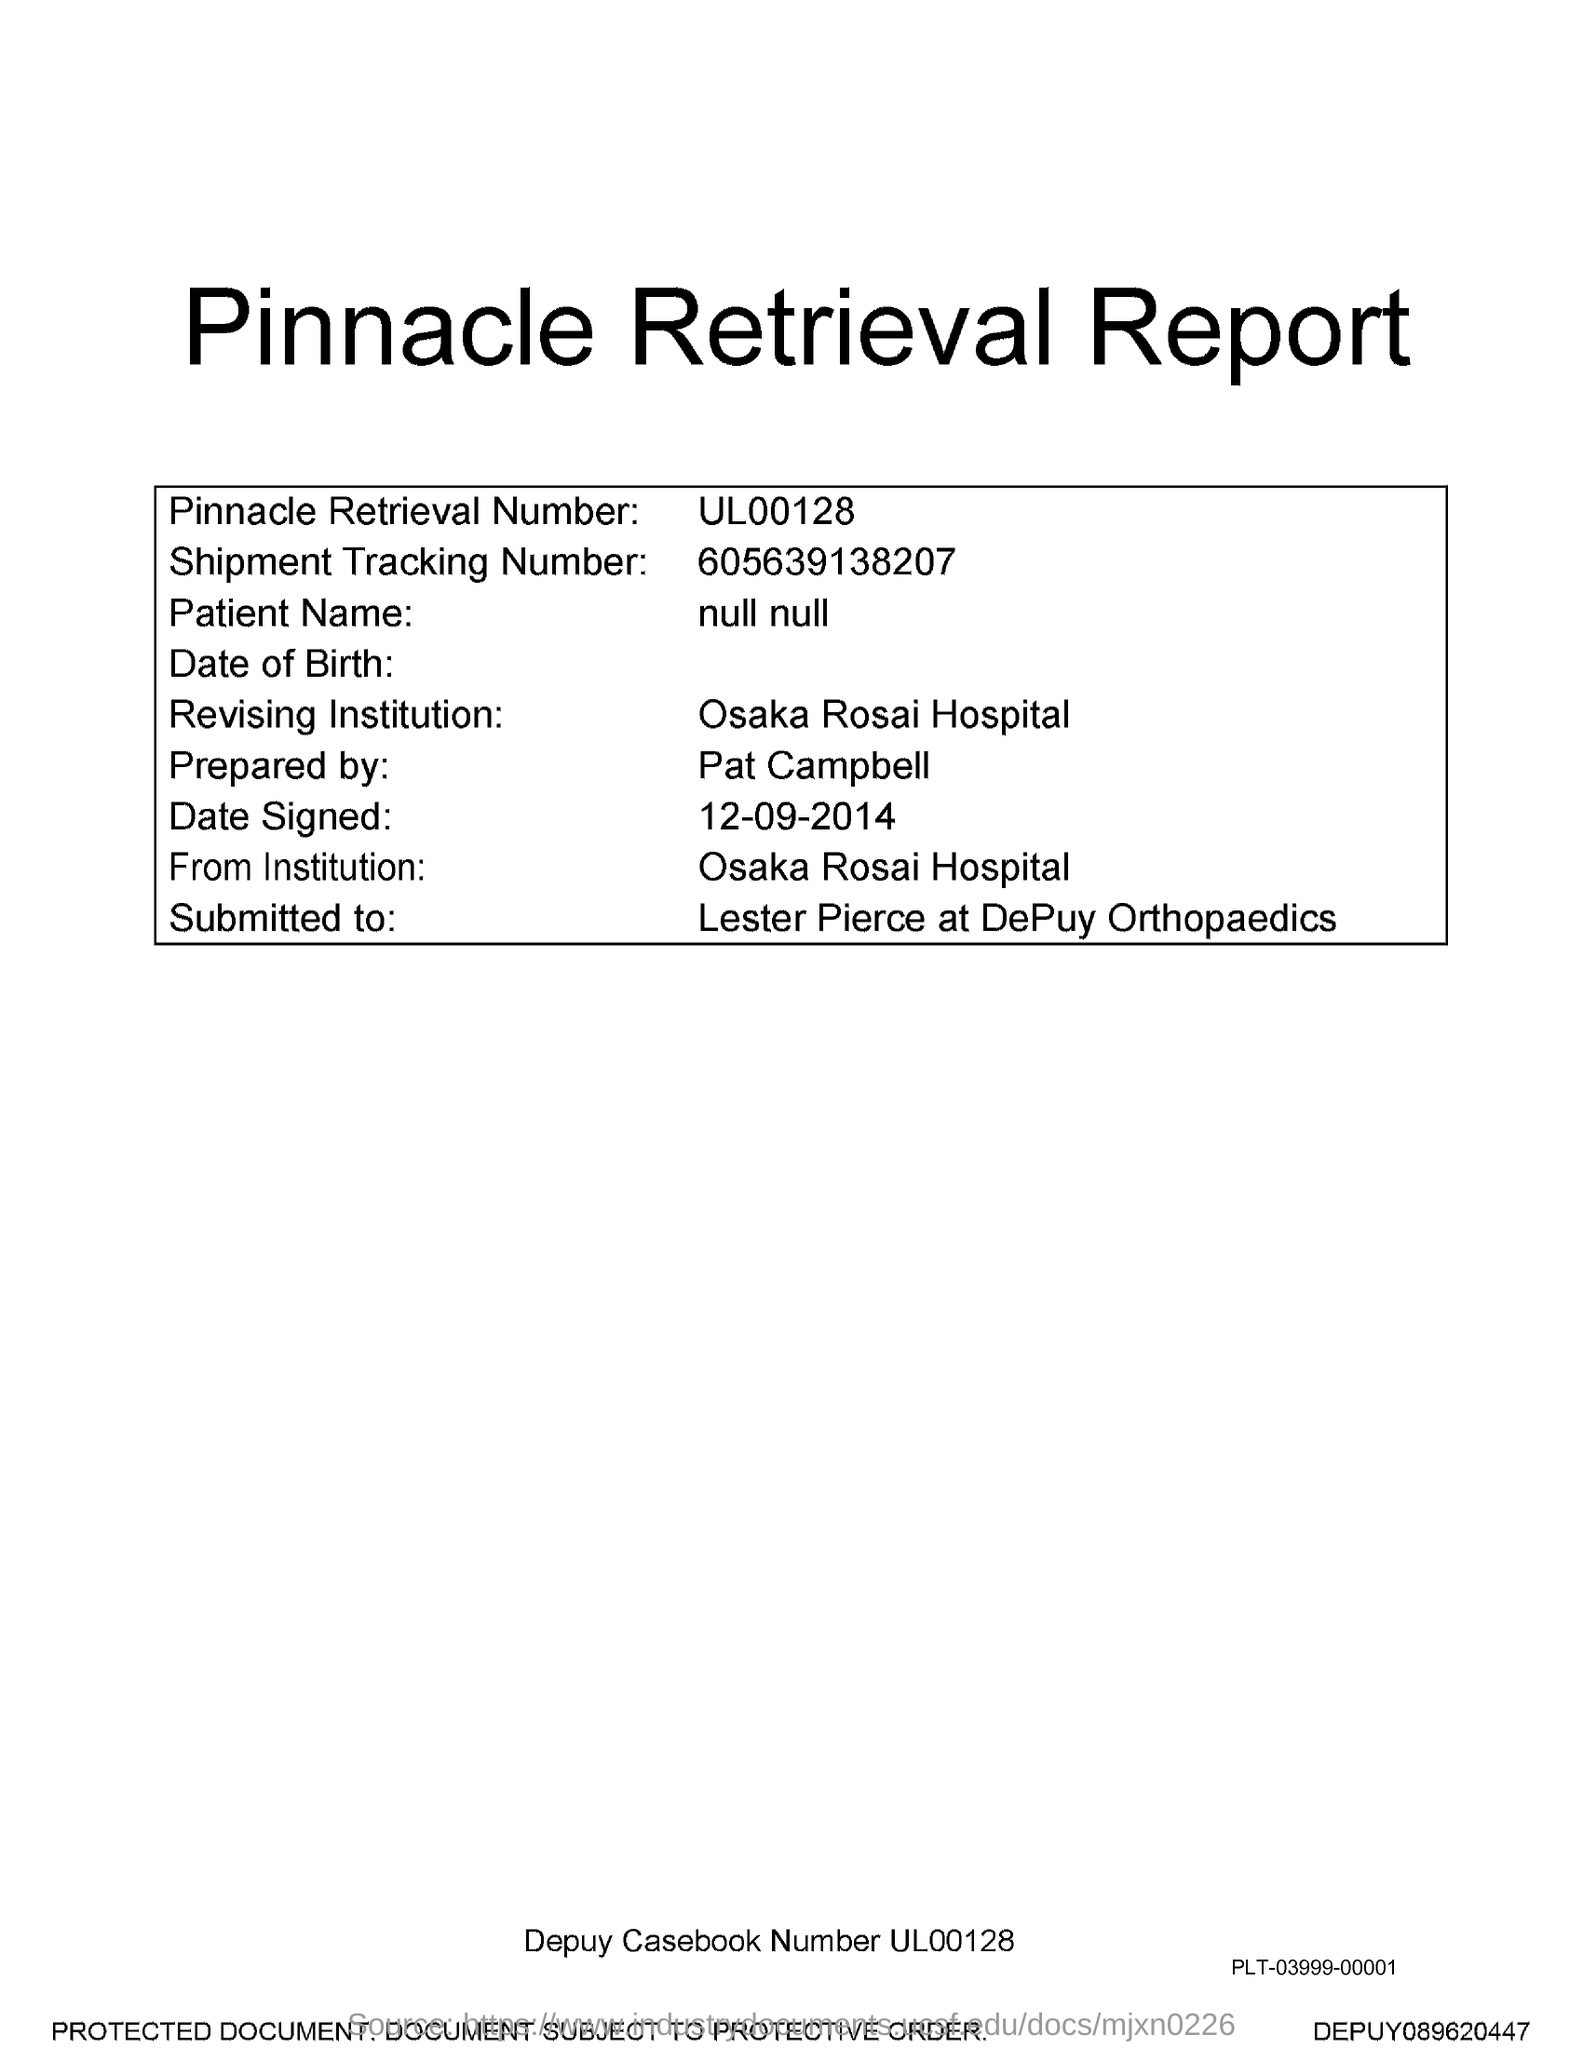Point out several critical features in this image. The title of the document is the Pinnacle Retrieval Report. The Pinnacle Retrieval Number is a unique identifier assigned to a specific product or service offered by a company. The specific number is UL00128.. The shipment tracking number is 605639138207. 